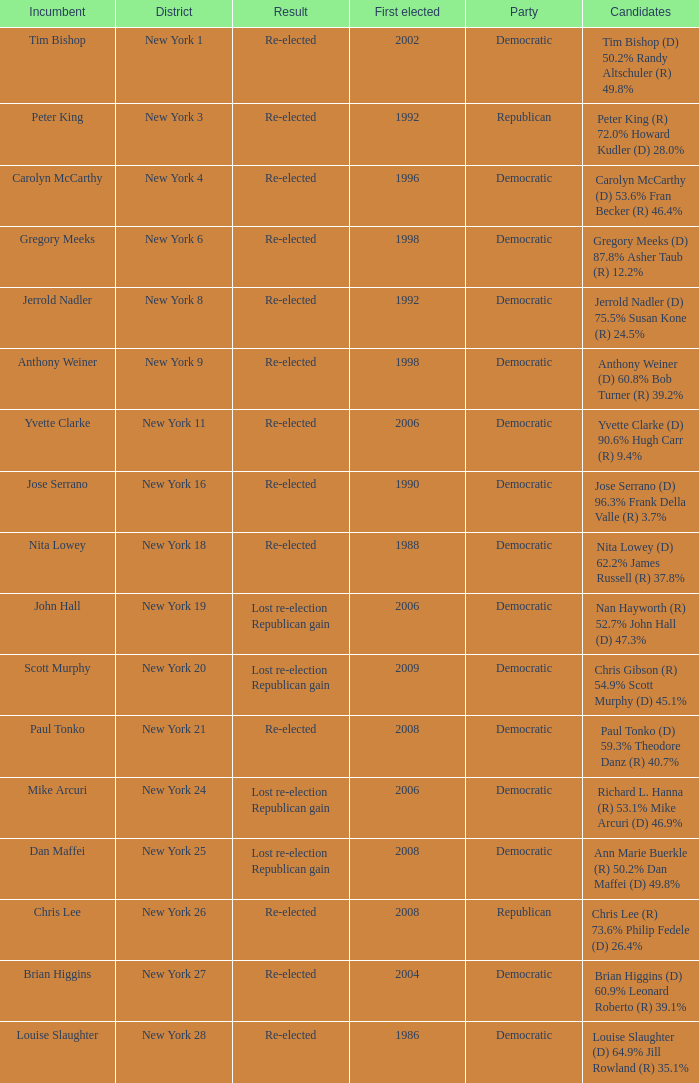Name the first elected for re-elected and brian higgins 2004.0. Could you help me parse every detail presented in this table? {'header': ['Incumbent', 'District', 'Result', 'First elected', 'Party', 'Candidates'], 'rows': [['Tim Bishop', 'New York 1', 'Re-elected', '2002', 'Democratic', 'Tim Bishop (D) 50.2% Randy Altschuler (R) 49.8%'], ['Peter King', 'New York 3', 'Re-elected', '1992', 'Republican', 'Peter King (R) 72.0% Howard Kudler (D) 28.0%'], ['Carolyn McCarthy', 'New York 4', 'Re-elected', '1996', 'Democratic', 'Carolyn McCarthy (D) 53.6% Fran Becker (R) 46.4%'], ['Gregory Meeks', 'New York 6', 'Re-elected', '1998', 'Democratic', 'Gregory Meeks (D) 87.8% Asher Taub (R) 12.2%'], ['Jerrold Nadler', 'New York 8', 'Re-elected', '1992', 'Democratic', 'Jerrold Nadler (D) 75.5% Susan Kone (R) 24.5%'], ['Anthony Weiner', 'New York 9', 'Re-elected', '1998', 'Democratic', 'Anthony Weiner (D) 60.8% Bob Turner (R) 39.2%'], ['Yvette Clarke', 'New York 11', 'Re-elected', '2006', 'Democratic', 'Yvette Clarke (D) 90.6% Hugh Carr (R) 9.4%'], ['Jose Serrano', 'New York 16', 'Re-elected', '1990', 'Democratic', 'Jose Serrano (D) 96.3% Frank Della Valle (R) 3.7%'], ['Nita Lowey', 'New York 18', 'Re-elected', '1988', 'Democratic', 'Nita Lowey (D) 62.2% James Russell (R) 37.8%'], ['John Hall', 'New York 19', 'Lost re-election Republican gain', '2006', 'Democratic', 'Nan Hayworth (R) 52.7% John Hall (D) 47.3%'], ['Scott Murphy', 'New York 20', 'Lost re-election Republican gain', '2009', 'Democratic', 'Chris Gibson (R) 54.9% Scott Murphy (D) 45.1%'], ['Paul Tonko', 'New York 21', 'Re-elected', '2008', 'Democratic', 'Paul Tonko (D) 59.3% Theodore Danz (R) 40.7%'], ['Mike Arcuri', 'New York 24', 'Lost re-election Republican gain', '2006', 'Democratic', 'Richard L. Hanna (R) 53.1% Mike Arcuri (D) 46.9%'], ['Dan Maffei', 'New York 25', 'Lost re-election Republican gain', '2008', 'Democratic', 'Ann Marie Buerkle (R) 50.2% Dan Maffei (D) 49.8%'], ['Chris Lee', 'New York 26', 'Re-elected', '2008', 'Republican', 'Chris Lee (R) 73.6% Philip Fedele (D) 26.4%'], ['Brian Higgins', 'New York 27', 'Re-elected', '2004', 'Democratic', 'Brian Higgins (D) 60.9% Leonard Roberto (R) 39.1%'], ['Louise Slaughter', 'New York 28', 'Re-elected', '1986', 'Democratic', 'Louise Slaughter (D) 64.9% Jill Rowland (R) 35.1%']]} 